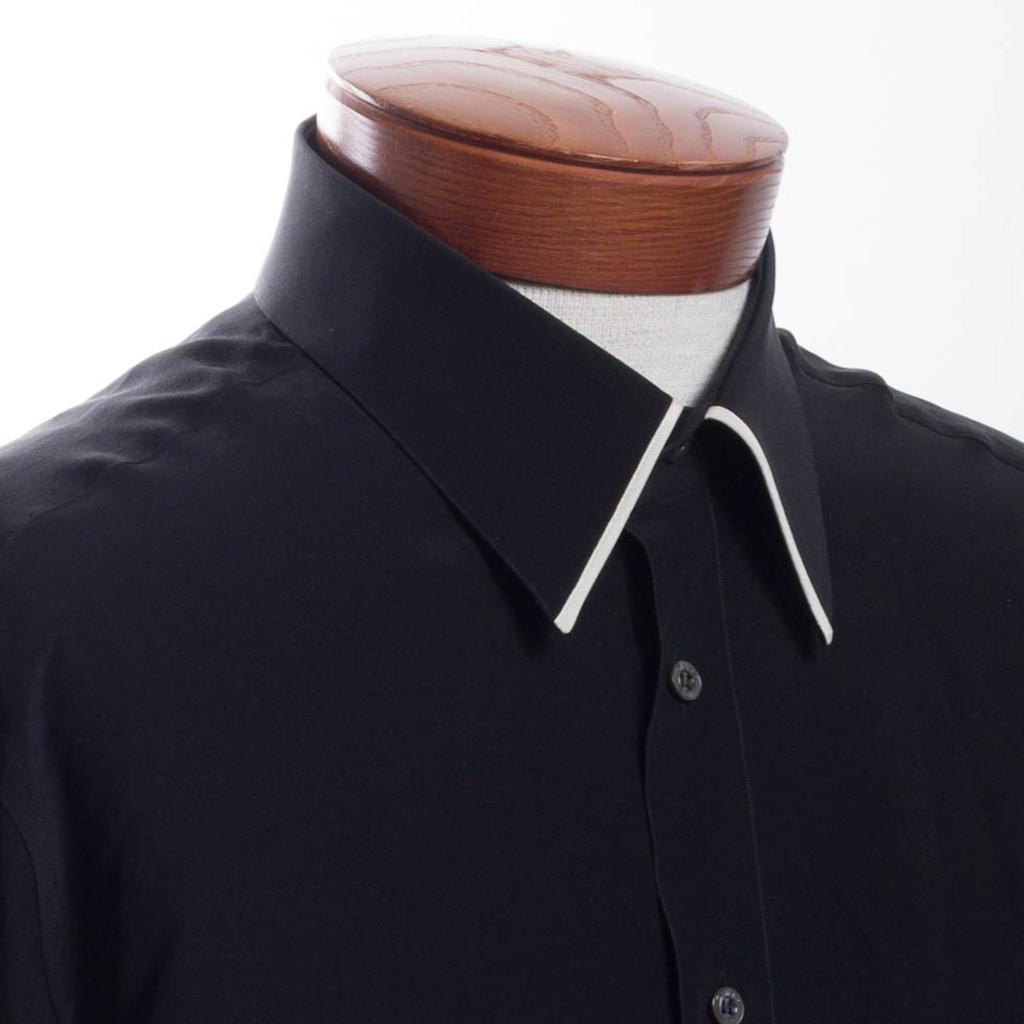What type of clothing item is in the image? There is a shirt in the image. What is the object that the shirt is placed on? There is a mannequin in the image. What color is the background of the image? The background of the image is white. How many friends are visible in the image? There are no friends present in the image; it only features a shirt on a mannequin against a white background. 